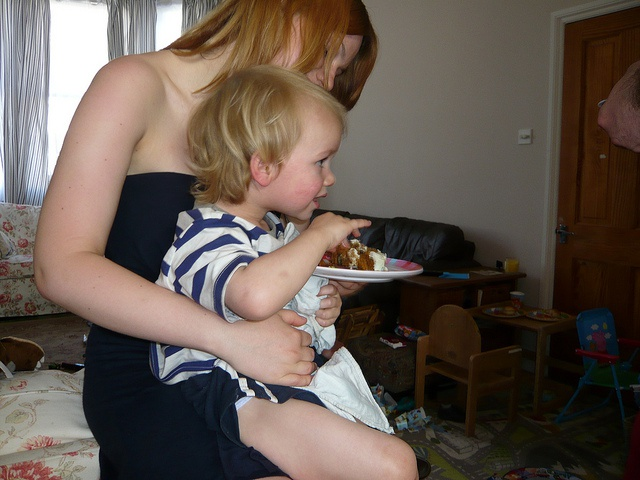Describe the objects in this image and their specific colors. I can see people in darkgray, black, and tan tones, people in darkgray, gray, maroon, and tan tones, bed in darkgray and gray tones, chair in black, maroon, and darkgray tones, and couch in darkgray, black, and gray tones in this image. 